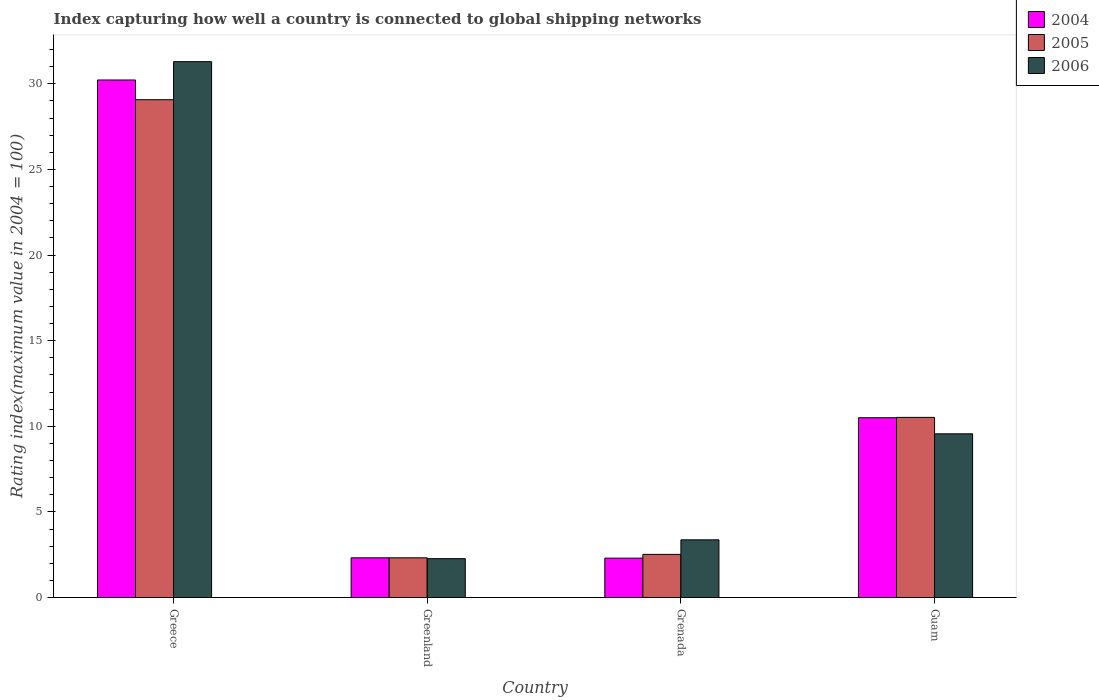How many different coloured bars are there?
Ensure brevity in your answer.  3. How many groups of bars are there?
Your response must be concise. 4. Are the number of bars per tick equal to the number of legend labels?
Provide a succinct answer. Yes. Are the number of bars on each tick of the X-axis equal?
Make the answer very short. Yes. How many bars are there on the 1st tick from the left?
Offer a very short reply. 3. What is the label of the 2nd group of bars from the left?
Your answer should be compact. Greenland. What is the rating index in 2006 in Grenada?
Make the answer very short. 3.37. Across all countries, what is the maximum rating index in 2005?
Your answer should be compact. 29.07. Across all countries, what is the minimum rating index in 2005?
Provide a succinct answer. 2.32. In which country was the rating index in 2006 minimum?
Provide a succinct answer. Greenland. What is the total rating index in 2005 in the graph?
Keep it short and to the point. 44.43. What is the difference between the rating index in 2004 in Grenada and the rating index in 2006 in Greece?
Keep it short and to the point. -28.99. What is the average rating index in 2005 per country?
Provide a short and direct response. 11.11. What is the difference between the rating index of/in 2006 and rating index of/in 2004 in Grenada?
Ensure brevity in your answer.  1.07. In how many countries, is the rating index in 2004 greater than 18?
Make the answer very short. 1. What is the ratio of the rating index in 2004 in Greece to that in Guam?
Offer a very short reply. 2.88. Is the rating index in 2005 in Greenland less than that in Guam?
Ensure brevity in your answer.  Yes. Is the difference between the rating index in 2006 in Greece and Greenland greater than the difference between the rating index in 2004 in Greece and Greenland?
Keep it short and to the point. Yes. What is the difference between the highest and the lowest rating index in 2005?
Offer a terse response. 26.75. Is the sum of the rating index in 2004 in Grenada and Guam greater than the maximum rating index in 2006 across all countries?
Provide a succinct answer. No. How many bars are there?
Ensure brevity in your answer.  12. Are all the bars in the graph horizontal?
Offer a very short reply. No. What is the difference between two consecutive major ticks on the Y-axis?
Your response must be concise. 5. Are the values on the major ticks of Y-axis written in scientific E-notation?
Give a very brief answer. No. How many legend labels are there?
Ensure brevity in your answer.  3. What is the title of the graph?
Offer a terse response. Index capturing how well a country is connected to global shipping networks. What is the label or title of the X-axis?
Provide a short and direct response. Country. What is the label or title of the Y-axis?
Ensure brevity in your answer.  Rating index(maximum value in 2004 = 100). What is the Rating index(maximum value in 2004 = 100) in 2004 in Greece?
Make the answer very short. 30.22. What is the Rating index(maximum value in 2004 = 100) of 2005 in Greece?
Offer a very short reply. 29.07. What is the Rating index(maximum value in 2004 = 100) of 2006 in Greece?
Your answer should be very brief. 31.29. What is the Rating index(maximum value in 2004 = 100) of 2004 in Greenland?
Keep it short and to the point. 2.32. What is the Rating index(maximum value in 2004 = 100) in 2005 in Greenland?
Make the answer very short. 2.32. What is the Rating index(maximum value in 2004 = 100) of 2006 in Greenland?
Give a very brief answer. 2.27. What is the Rating index(maximum value in 2004 = 100) in 2004 in Grenada?
Your response must be concise. 2.3. What is the Rating index(maximum value in 2004 = 100) in 2005 in Grenada?
Offer a very short reply. 2.52. What is the Rating index(maximum value in 2004 = 100) in 2006 in Grenada?
Your answer should be compact. 3.37. What is the Rating index(maximum value in 2004 = 100) in 2004 in Guam?
Offer a very short reply. 10.5. What is the Rating index(maximum value in 2004 = 100) in 2005 in Guam?
Your response must be concise. 10.52. What is the Rating index(maximum value in 2004 = 100) in 2006 in Guam?
Ensure brevity in your answer.  9.56. Across all countries, what is the maximum Rating index(maximum value in 2004 = 100) in 2004?
Offer a very short reply. 30.22. Across all countries, what is the maximum Rating index(maximum value in 2004 = 100) of 2005?
Ensure brevity in your answer.  29.07. Across all countries, what is the maximum Rating index(maximum value in 2004 = 100) in 2006?
Ensure brevity in your answer.  31.29. Across all countries, what is the minimum Rating index(maximum value in 2004 = 100) in 2004?
Your response must be concise. 2.3. Across all countries, what is the minimum Rating index(maximum value in 2004 = 100) in 2005?
Your response must be concise. 2.32. Across all countries, what is the minimum Rating index(maximum value in 2004 = 100) of 2006?
Offer a very short reply. 2.27. What is the total Rating index(maximum value in 2004 = 100) in 2004 in the graph?
Ensure brevity in your answer.  45.34. What is the total Rating index(maximum value in 2004 = 100) in 2005 in the graph?
Provide a succinct answer. 44.43. What is the total Rating index(maximum value in 2004 = 100) of 2006 in the graph?
Your answer should be compact. 46.49. What is the difference between the Rating index(maximum value in 2004 = 100) in 2004 in Greece and that in Greenland?
Keep it short and to the point. 27.9. What is the difference between the Rating index(maximum value in 2004 = 100) in 2005 in Greece and that in Greenland?
Provide a succinct answer. 26.75. What is the difference between the Rating index(maximum value in 2004 = 100) in 2006 in Greece and that in Greenland?
Provide a succinct answer. 29.02. What is the difference between the Rating index(maximum value in 2004 = 100) in 2004 in Greece and that in Grenada?
Provide a succinct answer. 27.92. What is the difference between the Rating index(maximum value in 2004 = 100) of 2005 in Greece and that in Grenada?
Provide a short and direct response. 26.55. What is the difference between the Rating index(maximum value in 2004 = 100) in 2006 in Greece and that in Grenada?
Keep it short and to the point. 27.92. What is the difference between the Rating index(maximum value in 2004 = 100) of 2004 in Greece and that in Guam?
Offer a terse response. 19.72. What is the difference between the Rating index(maximum value in 2004 = 100) in 2005 in Greece and that in Guam?
Your response must be concise. 18.55. What is the difference between the Rating index(maximum value in 2004 = 100) in 2006 in Greece and that in Guam?
Give a very brief answer. 21.73. What is the difference between the Rating index(maximum value in 2004 = 100) in 2006 in Greenland and that in Grenada?
Provide a succinct answer. -1.1. What is the difference between the Rating index(maximum value in 2004 = 100) in 2004 in Greenland and that in Guam?
Offer a very short reply. -8.18. What is the difference between the Rating index(maximum value in 2004 = 100) in 2006 in Greenland and that in Guam?
Your response must be concise. -7.29. What is the difference between the Rating index(maximum value in 2004 = 100) in 2006 in Grenada and that in Guam?
Your answer should be very brief. -6.19. What is the difference between the Rating index(maximum value in 2004 = 100) in 2004 in Greece and the Rating index(maximum value in 2004 = 100) in 2005 in Greenland?
Give a very brief answer. 27.9. What is the difference between the Rating index(maximum value in 2004 = 100) in 2004 in Greece and the Rating index(maximum value in 2004 = 100) in 2006 in Greenland?
Provide a succinct answer. 27.95. What is the difference between the Rating index(maximum value in 2004 = 100) in 2005 in Greece and the Rating index(maximum value in 2004 = 100) in 2006 in Greenland?
Make the answer very short. 26.8. What is the difference between the Rating index(maximum value in 2004 = 100) of 2004 in Greece and the Rating index(maximum value in 2004 = 100) of 2005 in Grenada?
Offer a very short reply. 27.7. What is the difference between the Rating index(maximum value in 2004 = 100) of 2004 in Greece and the Rating index(maximum value in 2004 = 100) of 2006 in Grenada?
Your answer should be compact. 26.85. What is the difference between the Rating index(maximum value in 2004 = 100) of 2005 in Greece and the Rating index(maximum value in 2004 = 100) of 2006 in Grenada?
Make the answer very short. 25.7. What is the difference between the Rating index(maximum value in 2004 = 100) in 2004 in Greece and the Rating index(maximum value in 2004 = 100) in 2006 in Guam?
Make the answer very short. 20.66. What is the difference between the Rating index(maximum value in 2004 = 100) of 2005 in Greece and the Rating index(maximum value in 2004 = 100) of 2006 in Guam?
Provide a short and direct response. 19.51. What is the difference between the Rating index(maximum value in 2004 = 100) of 2004 in Greenland and the Rating index(maximum value in 2004 = 100) of 2005 in Grenada?
Provide a succinct answer. -0.2. What is the difference between the Rating index(maximum value in 2004 = 100) in 2004 in Greenland and the Rating index(maximum value in 2004 = 100) in 2006 in Grenada?
Your answer should be compact. -1.05. What is the difference between the Rating index(maximum value in 2004 = 100) of 2005 in Greenland and the Rating index(maximum value in 2004 = 100) of 2006 in Grenada?
Provide a succinct answer. -1.05. What is the difference between the Rating index(maximum value in 2004 = 100) of 2004 in Greenland and the Rating index(maximum value in 2004 = 100) of 2005 in Guam?
Offer a very short reply. -8.2. What is the difference between the Rating index(maximum value in 2004 = 100) of 2004 in Greenland and the Rating index(maximum value in 2004 = 100) of 2006 in Guam?
Provide a succinct answer. -7.24. What is the difference between the Rating index(maximum value in 2004 = 100) of 2005 in Greenland and the Rating index(maximum value in 2004 = 100) of 2006 in Guam?
Offer a terse response. -7.24. What is the difference between the Rating index(maximum value in 2004 = 100) of 2004 in Grenada and the Rating index(maximum value in 2004 = 100) of 2005 in Guam?
Provide a short and direct response. -8.22. What is the difference between the Rating index(maximum value in 2004 = 100) in 2004 in Grenada and the Rating index(maximum value in 2004 = 100) in 2006 in Guam?
Keep it short and to the point. -7.26. What is the difference between the Rating index(maximum value in 2004 = 100) of 2005 in Grenada and the Rating index(maximum value in 2004 = 100) of 2006 in Guam?
Ensure brevity in your answer.  -7.04. What is the average Rating index(maximum value in 2004 = 100) in 2004 per country?
Ensure brevity in your answer.  11.34. What is the average Rating index(maximum value in 2004 = 100) in 2005 per country?
Give a very brief answer. 11.11. What is the average Rating index(maximum value in 2004 = 100) in 2006 per country?
Offer a very short reply. 11.62. What is the difference between the Rating index(maximum value in 2004 = 100) of 2004 and Rating index(maximum value in 2004 = 100) of 2005 in Greece?
Your answer should be compact. 1.15. What is the difference between the Rating index(maximum value in 2004 = 100) in 2004 and Rating index(maximum value in 2004 = 100) in 2006 in Greece?
Give a very brief answer. -1.07. What is the difference between the Rating index(maximum value in 2004 = 100) of 2005 and Rating index(maximum value in 2004 = 100) of 2006 in Greece?
Offer a very short reply. -2.22. What is the difference between the Rating index(maximum value in 2004 = 100) in 2004 and Rating index(maximum value in 2004 = 100) in 2005 in Greenland?
Your response must be concise. 0. What is the difference between the Rating index(maximum value in 2004 = 100) of 2004 and Rating index(maximum value in 2004 = 100) of 2006 in Greenland?
Your answer should be very brief. 0.05. What is the difference between the Rating index(maximum value in 2004 = 100) in 2004 and Rating index(maximum value in 2004 = 100) in 2005 in Grenada?
Offer a terse response. -0.22. What is the difference between the Rating index(maximum value in 2004 = 100) in 2004 and Rating index(maximum value in 2004 = 100) in 2006 in Grenada?
Your answer should be compact. -1.07. What is the difference between the Rating index(maximum value in 2004 = 100) in 2005 and Rating index(maximum value in 2004 = 100) in 2006 in Grenada?
Your answer should be very brief. -0.85. What is the difference between the Rating index(maximum value in 2004 = 100) in 2004 and Rating index(maximum value in 2004 = 100) in 2005 in Guam?
Provide a short and direct response. -0.02. What is the difference between the Rating index(maximum value in 2004 = 100) of 2004 and Rating index(maximum value in 2004 = 100) of 2006 in Guam?
Keep it short and to the point. 0.94. What is the difference between the Rating index(maximum value in 2004 = 100) in 2005 and Rating index(maximum value in 2004 = 100) in 2006 in Guam?
Offer a terse response. 0.96. What is the ratio of the Rating index(maximum value in 2004 = 100) of 2004 in Greece to that in Greenland?
Your answer should be very brief. 13.03. What is the ratio of the Rating index(maximum value in 2004 = 100) in 2005 in Greece to that in Greenland?
Your answer should be very brief. 12.53. What is the ratio of the Rating index(maximum value in 2004 = 100) in 2006 in Greece to that in Greenland?
Offer a terse response. 13.78. What is the ratio of the Rating index(maximum value in 2004 = 100) of 2004 in Greece to that in Grenada?
Your response must be concise. 13.14. What is the ratio of the Rating index(maximum value in 2004 = 100) in 2005 in Greece to that in Grenada?
Provide a succinct answer. 11.54. What is the ratio of the Rating index(maximum value in 2004 = 100) in 2006 in Greece to that in Grenada?
Your answer should be compact. 9.28. What is the ratio of the Rating index(maximum value in 2004 = 100) of 2004 in Greece to that in Guam?
Ensure brevity in your answer.  2.88. What is the ratio of the Rating index(maximum value in 2004 = 100) in 2005 in Greece to that in Guam?
Provide a succinct answer. 2.76. What is the ratio of the Rating index(maximum value in 2004 = 100) in 2006 in Greece to that in Guam?
Your answer should be very brief. 3.27. What is the ratio of the Rating index(maximum value in 2004 = 100) of 2004 in Greenland to that in Grenada?
Your response must be concise. 1.01. What is the ratio of the Rating index(maximum value in 2004 = 100) of 2005 in Greenland to that in Grenada?
Provide a succinct answer. 0.92. What is the ratio of the Rating index(maximum value in 2004 = 100) of 2006 in Greenland to that in Grenada?
Your answer should be compact. 0.67. What is the ratio of the Rating index(maximum value in 2004 = 100) in 2004 in Greenland to that in Guam?
Offer a very short reply. 0.22. What is the ratio of the Rating index(maximum value in 2004 = 100) of 2005 in Greenland to that in Guam?
Make the answer very short. 0.22. What is the ratio of the Rating index(maximum value in 2004 = 100) of 2006 in Greenland to that in Guam?
Your answer should be very brief. 0.24. What is the ratio of the Rating index(maximum value in 2004 = 100) in 2004 in Grenada to that in Guam?
Your answer should be compact. 0.22. What is the ratio of the Rating index(maximum value in 2004 = 100) in 2005 in Grenada to that in Guam?
Make the answer very short. 0.24. What is the ratio of the Rating index(maximum value in 2004 = 100) in 2006 in Grenada to that in Guam?
Your response must be concise. 0.35. What is the difference between the highest and the second highest Rating index(maximum value in 2004 = 100) of 2004?
Ensure brevity in your answer.  19.72. What is the difference between the highest and the second highest Rating index(maximum value in 2004 = 100) in 2005?
Give a very brief answer. 18.55. What is the difference between the highest and the second highest Rating index(maximum value in 2004 = 100) of 2006?
Make the answer very short. 21.73. What is the difference between the highest and the lowest Rating index(maximum value in 2004 = 100) in 2004?
Your response must be concise. 27.92. What is the difference between the highest and the lowest Rating index(maximum value in 2004 = 100) in 2005?
Provide a succinct answer. 26.75. What is the difference between the highest and the lowest Rating index(maximum value in 2004 = 100) in 2006?
Make the answer very short. 29.02. 